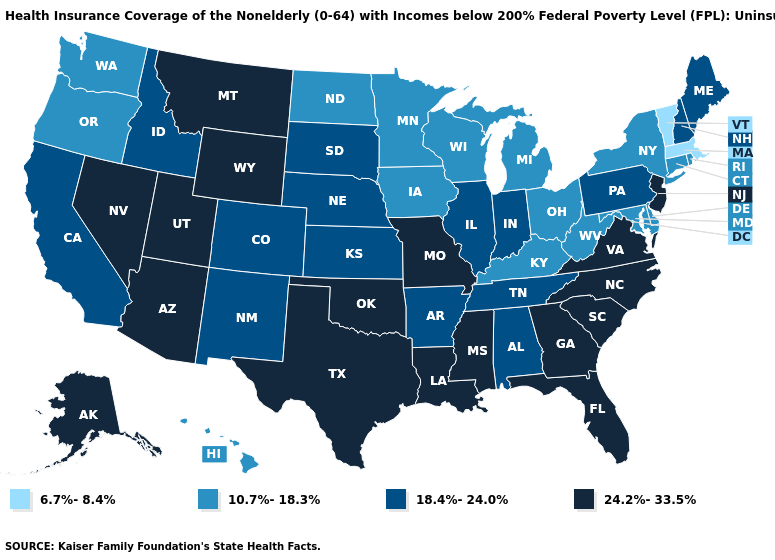Does Missouri have the highest value in the MidWest?
Keep it brief. Yes. Which states have the highest value in the USA?
Short answer required. Alaska, Arizona, Florida, Georgia, Louisiana, Mississippi, Missouri, Montana, Nevada, New Jersey, North Carolina, Oklahoma, South Carolina, Texas, Utah, Virginia, Wyoming. What is the value of Kansas?
Concise answer only. 18.4%-24.0%. Among the states that border Alabama , does Tennessee have the highest value?
Keep it brief. No. What is the value of Louisiana?
Concise answer only. 24.2%-33.5%. Name the states that have a value in the range 18.4%-24.0%?
Give a very brief answer. Alabama, Arkansas, California, Colorado, Idaho, Illinois, Indiana, Kansas, Maine, Nebraska, New Hampshire, New Mexico, Pennsylvania, South Dakota, Tennessee. Does Massachusetts have the highest value in the USA?
Concise answer only. No. Which states hav the highest value in the West?
Answer briefly. Alaska, Arizona, Montana, Nevada, Utah, Wyoming. What is the highest value in the USA?
Answer briefly. 24.2%-33.5%. Does North Dakota have a higher value than Idaho?
Short answer required. No. Among the states that border Wisconsin , does Illinois have the highest value?
Quick response, please. Yes. Among the states that border Delaware , which have the lowest value?
Be succinct. Maryland. Does Vermont have the lowest value in the USA?
Keep it brief. Yes. What is the lowest value in the USA?
Short answer required. 6.7%-8.4%. Does Michigan have a lower value than Connecticut?
Concise answer only. No. 